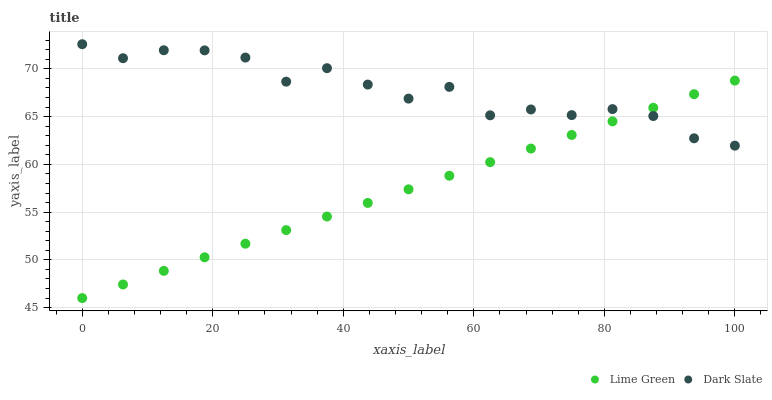Does Lime Green have the minimum area under the curve?
Answer yes or no. Yes. Does Dark Slate have the maximum area under the curve?
Answer yes or no. Yes. Does Lime Green have the maximum area under the curve?
Answer yes or no. No. Is Lime Green the smoothest?
Answer yes or no. Yes. Is Dark Slate the roughest?
Answer yes or no. Yes. Is Lime Green the roughest?
Answer yes or no. No. Does Lime Green have the lowest value?
Answer yes or no. Yes. Does Dark Slate have the highest value?
Answer yes or no. Yes. Does Lime Green have the highest value?
Answer yes or no. No. Does Lime Green intersect Dark Slate?
Answer yes or no. Yes. Is Lime Green less than Dark Slate?
Answer yes or no. No. Is Lime Green greater than Dark Slate?
Answer yes or no. No. 